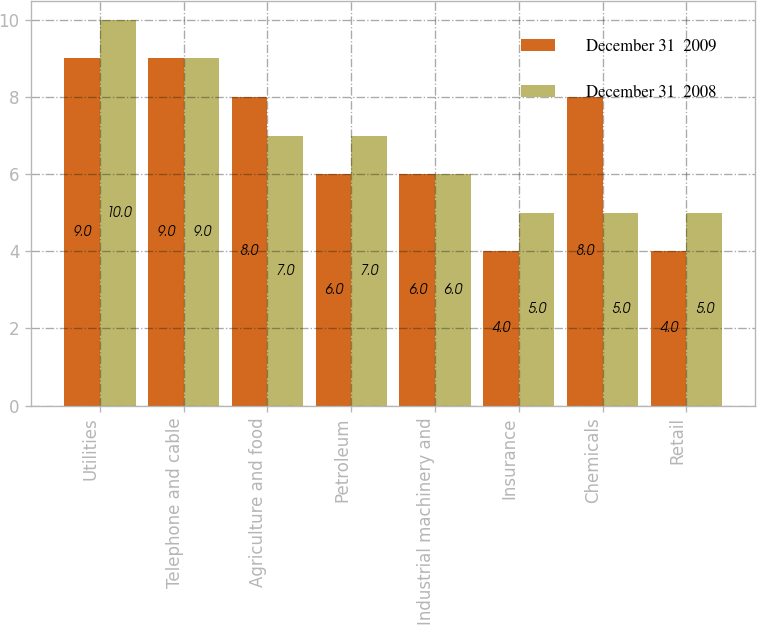<chart> <loc_0><loc_0><loc_500><loc_500><stacked_bar_chart><ecel><fcel>Utilities<fcel>Telephone and cable<fcel>Agriculture and food<fcel>Petroleum<fcel>Industrial machinery and<fcel>Insurance<fcel>Chemicals<fcel>Retail<nl><fcel>December 31  2009<fcel>9<fcel>9<fcel>8<fcel>6<fcel>6<fcel>4<fcel>8<fcel>4<nl><fcel>December 31  2008<fcel>10<fcel>9<fcel>7<fcel>7<fcel>6<fcel>5<fcel>5<fcel>5<nl></chart> 